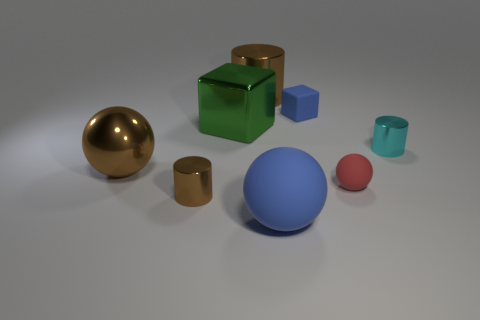Add 2 green metallic blocks. How many objects exist? 10 Subtract all cylinders. How many objects are left? 5 Subtract all large rubber objects. Subtract all tiny rubber balls. How many objects are left? 6 Add 1 green metallic objects. How many green metallic objects are left? 2 Add 6 blue blocks. How many blue blocks exist? 7 Subtract 0 green balls. How many objects are left? 8 